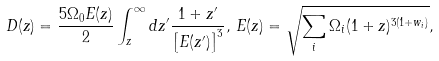<formula> <loc_0><loc_0><loc_500><loc_500>D ( z ) = \frac { 5 \Omega _ { 0 } E ( z ) } { 2 } \int _ { z } ^ { \infty } d z ^ { \prime } \frac { 1 + z ^ { \prime } } { \left [ E ( z ^ { \prime } ) \right ] ^ { 3 } } , \, E ( z ) = \sqrt { \sum _ { i } \Omega _ { i } ( 1 + z ) ^ { 3 ( 1 + w _ { i } ) } } ,</formula> 